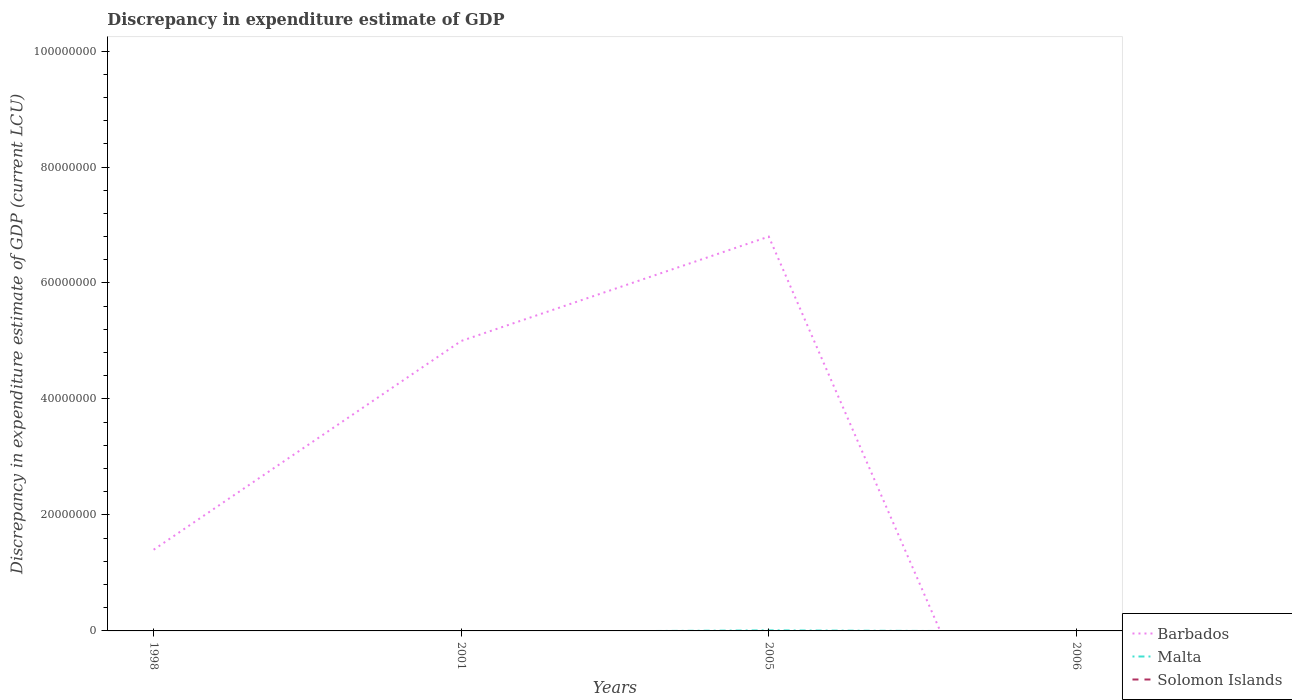How many different coloured lines are there?
Keep it short and to the point. 2. Across all years, what is the maximum discrepancy in expenditure estimate of GDP in Malta?
Offer a terse response. 0. How many years are there in the graph?
Your response must be concise. 4. What is the difference between two consecutive major ticks on the Y-axis?
Give a very brief answer. 2.00e+07. Does the graph contain grids?
Keep it short and to the point. No. Where does the legend appear in the graph?
Your answer should be compact. Bottom right. What is the title of the graph?
Keep it short and to the point. Discrepancy in expenditure estimate of GDP. What is the label or title of the Y-axis?
Provide a succinct answer. Discrepancy in expenditure estimate of GDP (current LCU). What is the Discrepancy in expenditure estimate of GDP (current LCU) of Barbados in 1998?
Ensure brevity in your answer.  1.40e+07. What is the Discrepancy in expenditure estimate of GDP (current LCU) of Barbados in 2001?
Provide a succinct answer. 5.00e+07. What is the Discrepancy in expenditure estimate of GDP (current LCU) in Barbados in 2005?
Provide a succinct answer. 6.80e+07. What is the Discrepancy in expenditure estimate of GDP (current LCU) in Barbados in 2006?
Your answer should be compact. 0. What is the Discrepancy in expenditure estimate of GDP (current LCU) in Solomon Islands in 2006?
Your response must be concise. 0. Across all years, what is the maximum Discrepancy in expenditure estimate of GDP (current LCU) in Barbados?
Give a very brief answer. 6.80e+07. Across all years, what is the maximum Discrepancy in expenditure estimate of GDP (current LCU) in Malta?
Provide a succinct answer. 1.00e+05. Across all years, what is the minimum Discrepancy in expenditure estimate of GDP (current LCU) in Malta?
Your response must be concise. 0. What is the total Discrepancy in expenditure estimate of GDP (current LCU) in Barbados in the graph?
Offer a very short reply. 1.32e+08. What is the total Discrepancy in expenditure estimate of GDP (current LCU) in Solomon Islands in the graph?
Keep it short and to the point. 0. What is the difference between the Discrepancy in expenditure estimate of GDP (current LCU) of Barbados in 1998 and that in 2001?
Provide a short and direct response. -3.60e+07. What is the difference between the Discrepancy in expenditure estimate of GDP (current LCU) in Barbados in 1998 and that in 2005?
Keep it short and to the point. -5.40e+07. What is the difference between the Discrepancy in expenditure estimate of GDP (current LCU) in Barbados in 2001 and that in 2005?
Your answer should be compact. -1.80e+07. What is the difference between the Discrepancy in expenditure estimate of GDP (current LCU) of Barbados in 1998 and the Discrepancy in expenditure estimate of GDP (current LCU) of Malta in 2005?
Offer a terse response. 1.39e+07. What is the difference between the Discrepancy in expenditure estimate of GDP (current LCU) of Barbados in 2001 and the Discrepancy in expenditure estimate of GDP (current LCU) of Malta in 2005?
Your answer should be very brief. 4.99e+07. What is the average Discrepancy in expenditure estimate of GDP (current LCU) of Barbados per year?
Your answer should be very brief. 3.30e+07. What is the average Discrepancy in expenditure estimate of GDP (current LCU) in Malta per year?
Make the answer very short. 2.50e+04. In the year 2005, what is the difference between the Discrepancy in expenditure estimate of GDP (current LCU) of Barbados and Discrepancy in expenditure estimate of GDP (current LCU) of Malta?
Provide a short and direct response. 6.79e+07. What is the ratio of the Discrepancy in expenditure estimate of GDP (current LCU) in Barbados in 1998 to that in 2001?
Offer a terse response. 0.28. What is the ratio of the Discrepancy in expenditure estimate of GDP (current LCU) of Barbados in 1998 to that in 2005?
Offer a very short reply. 0.21. What is the ratio of the Discrepancy in expenditure estimate of GDP (current LCU) in Barbados in 2001 to that in 2005?
Your response must be concise. 0.74. What is the difference between the highest and the second highest Discrepancy in expenditure estimate of GDP (current LCU) in Barbados?
Your answer should be very brief. 1.80e+07. What is the difference between the highest and the lowest Discrepancy in expenditure estimate of GDP (current LCU) in Barbados?
Ensure brevity in your answer.  6.80e+07. What is the difference between the highest and the lowest Discrepancy in expenditure estimate of GDP (current LCU) in Malta?
Keep it short and to the point. 1.00e+05. 